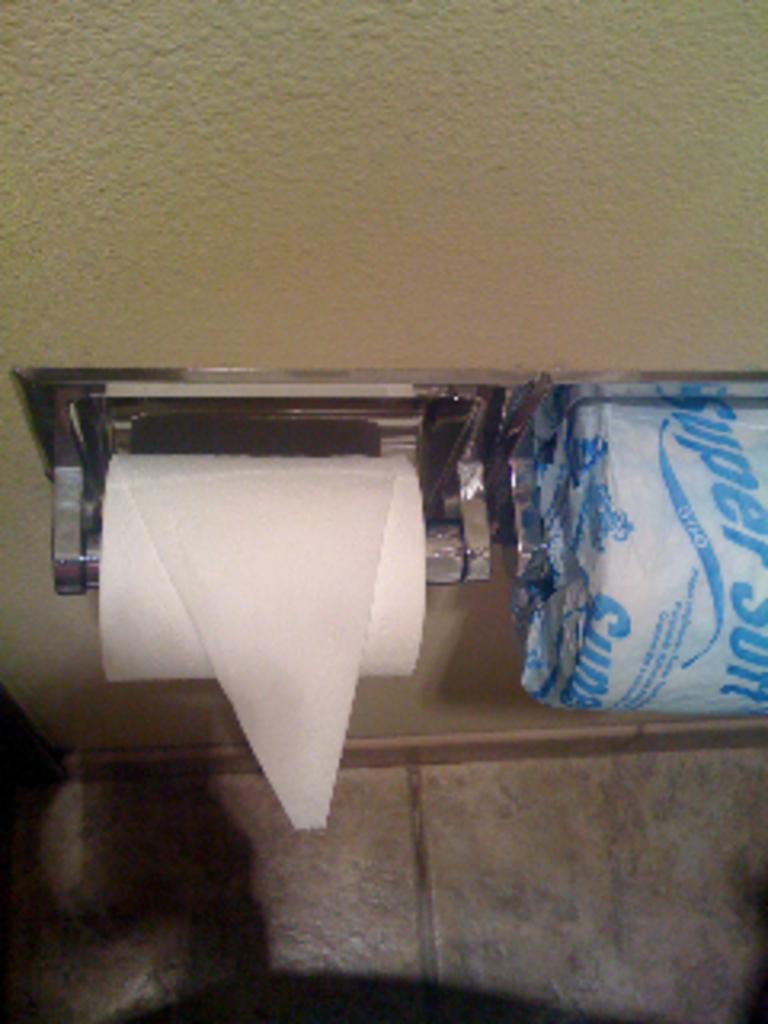What design is the toilet paper?
Offer a very short reply. Super soft. Who makes this tp?
Give a very brief answer. Super soft. 